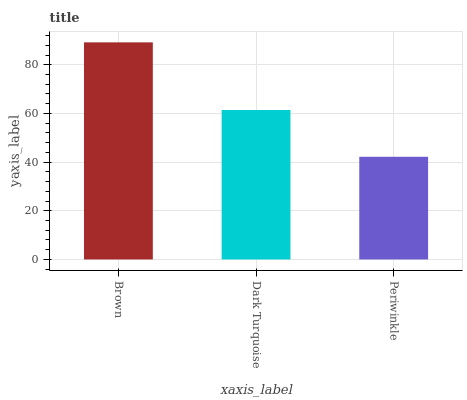Is Periwinkle the minimum?
Answer yes or no. Yes. Is Brown the maximum?
Answer yes or no. Yes. Is Dark Turquoise the minimum?
Answer yes or no. No. Is Dark Turquoise the maximum?
Answer yes or no. No. Is Brown greater than Dark Turquoise?
Answer yes or no. Yes. Is Dark Turquoise less than Brown?
Answer yes or no. Yes. Is Dark Turquoise greater than Brown?
Answer yes or no. No. Is Brown less than Dark Turquoise?
Answer yes or no. No. Is Dark Turquoise the high median?
Answer yes or no. Yes. Is Dark Turquoise the low median?
Answer yes or no. Yes. Is Periwinkle the high median?
Answer yes or no. No. Is Periwinkle the low median?
Answer yes or no. No. 